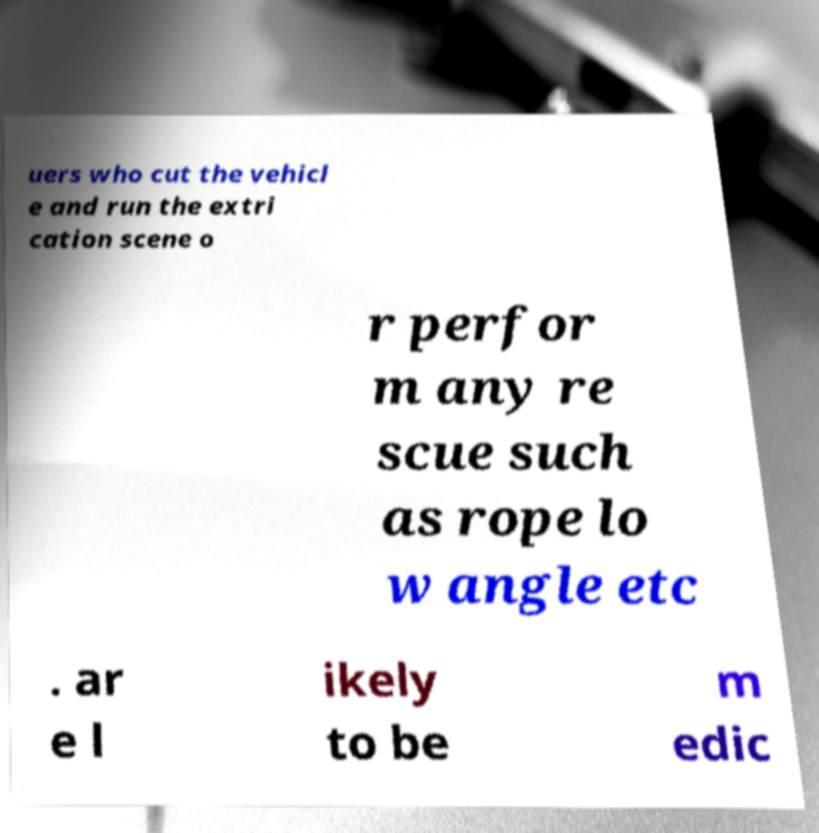Please read and relay the text visible in this image. What does it say? uers who cut the vehicl e and run the extri cation scene o r perfor m any re scue such as rope lo w angle etc . ar e l ikely to be m edic 